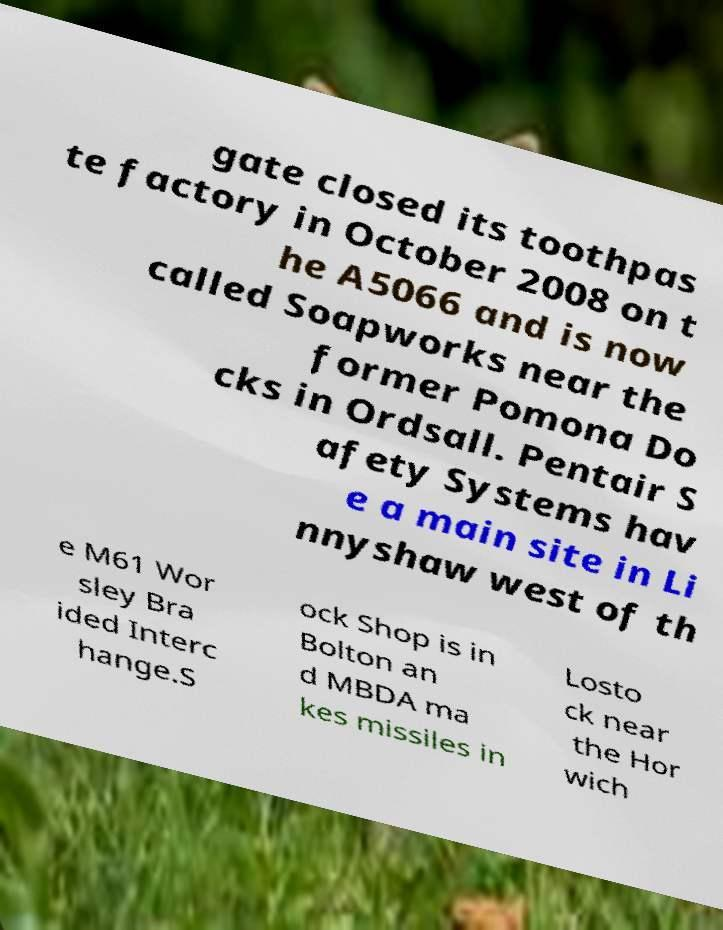Please read and relay the text visible in this image. What does it say? gate closed its toothpas te factory in October 2008 on t he A5066 and is now called Soapworks near the former Pomona Do cks in Ordsall. Pentair S afety Systems hav e a main site in Li nnyshaw west of th e M61 Wor sley Bra ided Interc hange.S ock Shop is in Bolton an d MBDA ma kes missiles in Losto ck near the Hor wich 